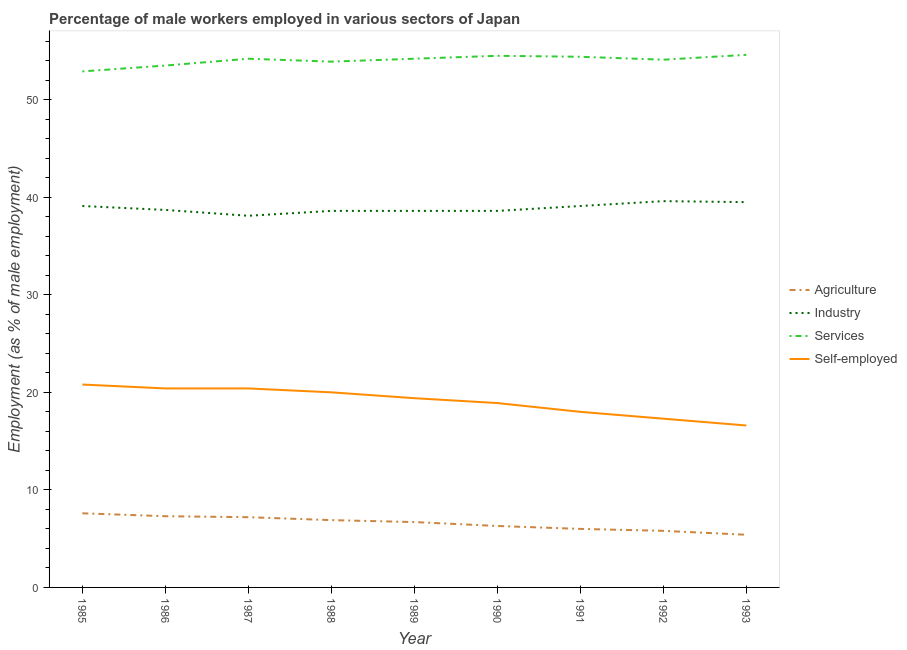How many different coloured lines are there?
Provide a succinct answer. 4. Is the number of lines equal to the number of legend labels?
Your response must be concise. Yes. What is the percentage of male workers in industry in 1992?
Offer a very short reply. 39.6. Across all years, what is the maximum percentage of self employed male workers?
Provide a short and direct response. 20.8. Across all years, what is the minimum percentage of male workers in industry?
Offer a terse response. 38.1. In which year was the percentage of self employed male workers maximum?
Ensure brevity in your answer.  1985. In which year was the percentage of self employed male workers minimum?
Keep it short and to the point. 1993. What is the total percentage of male workers in industry in the graph?
Ensure brevity in your answer.  349.9. What is the difference between the percentage of male workers in agriculture in 1985 and the percentage of male workers in industry in 1986?
Provide a short and direct response. -31.1. What is the average percentage of male workers in agriculture per year?
Give a very brief answer. 6.58. In the year 1985, what is the difference between the percentage of male workers in agriculture and percentage of male workers in industry?
Ensure brevity in your answer.  -31.5. Is the percentage of male workers in services in 1987 less than that in 1992?
Offer a terse response. No. What is the difference between the highest and the second highest percentage of male workers in agriculture?
Offer a very short reply. 0.3. What is the difference between the highest and the lowest percentage of self employed male workers?
Keep it short and to the point. 4.2. In how many years, is the percentage of male workers in agriculture greater than the average percentage of male workers in agriculture taken over all years?
Make the answer very short. 5. Is the sum of the percentage of male workers in industry in 1987 and 1992 greater than the maximum percentage of self employed male workers across all years?
Give a very brief answer. Yes. Is it the case that in every year, the sum of the percentage of male workers in services and percentage of self employed male workers is greater than the sum of percentage of male workers in agriculture and percentage of male workers in industry?
Provide a short and direct response. Yes. Is it the case that in every year, the sum of the percentage of male workers in agriculture and percentage of male workers in industry is greater than the percentage of male workers in services?
Give a very brief answer. No. Does the percentage of male workers in services monotonically increase over the years?
Your response must be concise. No. Is the percentage of male workers in industry strictly greater than the percentage of male workers in services over the years?
Ensure brevity in your answer.  No. Is the percentage of male workers in industry strictly less than the percentage of male workers in services over the years?
Offer a terse response. Yes. How many lines are there?
Keep it short and to the point. 4. Does the graph contain any zero values?
Offer a very short reply. No. What is the title of the graph?
Your answer should be compact. Percentage of male workers employed in various sectors of Japan. What is the label or title of the X-axis?
Your response must be concise. Year. What is the label or title of the Y-axis?
Your answer should be very brief. Employment (as % of male employment). What is the Employment (as % of male employment) in Agriculture in 1985?
Offer a very short reply. 7.6. What is the Employment (as % of male employment) of Industry in 1985?
Give a very brief answer. 39.1. What is the Employment (as % of male employment) of Services in 1985?
Offer a terse response. 52.9. What is the Employment (as % of male employment) of Self-employed in 1985?
Your answer should be very brief. 20.8. What is the Employment (as % of male employment) of Agriculture in 1986?
Make the answer very short. 7.3. What is the Employment (as % of male employment) in Industry in 1986?
Give a very brief answer. 38.7. What is the Employment (as % of male employment) of Services in 1986?
Offer a very short reply. 53.5. What is the Employment (as % of male employment) of Self-employed in 1986?
Your answer should be very brief. 20.4. What is the Employment (as % of male employment) of Agriculture in 1987?
Give a very brief answer. 7.2. What is the Employment (as % of male employment) in Industry in 1987?
Make the answer very short. 38.1. What is the Employment (as % of male employment) of Services in 1987?
Ensure brevity in your answer.  54.2. What is the Employment (as % of male employment) of Self-employed in 1987?
Your answer should be compact. 20.4. What is the Employment (as % of male employment) of Agriculture in 1988?
Make the answer very short. 6.9. What is the Employment (as % of male employment) of Industry in 1988?
Give a very brief answer. 38.6. What is the Employment (as % of male employment) in Services in 1988?
Give a very brief answer. 53.9. What is the Employment (as % of male employment) in Self-employed in 1988?
Provide a succinct answer. 20. What is the Employment (as % of male employment) of Agriculture in 1989?
Your response must be concise. 6.7. What is the Employment (as % of male employment) in Industry in 1989?
Your answer should be very brief. 38.6. What is the Employment (as % of male employment) in Services in 1989?
Provide a short and direct response. 54.2. What is the Employment (as % of male employment) of Self-employed in 1989?
Provide a short and direct response. 19.4. What is the Employment (as % of male employment) in Agriculture in 1990?
Provide a succinct answer. 6.3. What is the Employment (as % of male employment) of Industry in 1990?
Offer a terse response. 38.6. What is the Employment (as % of male employment) of Services in 1990?
Offer a very short reply. 54.5. What is the Employment (as % of male employment) in Self-employed in 1990?
Give a very brief answer. 18.9. What is the Employment (as % of male employment) in Industry in 1991?
Offer a terse response. 39.1. What is the Employment (as % of male employment) of Services in 1991?
Make the answer very short. 54.4. What is the Employment (as % of male employment) of Agriculture in 1992?
Offer a terse response. 5.8. What is the Employment (as % of male employment) in Industry in 1992?
Your answer should be compact. 39.6. What is the Employment (as % of male employment) in Services in 1992?
Offer a terse response. 54.1. What is the Employment (as % of male employment) of Self-employed in 1992?
Your answer should be very brief. 17.3. What is the Employment (as % of male employment) of Agriculture in 1993?
Your answer should be very brief. 5.4. What is the Employment (as % of male employment) of Industry in 1993?
Offer a terse response. 39.5. What is the Employment (as % of male employment) of Services in 1993?
Your answer should be very brief. 54.6. What is the Employment (as % of male employment) in Self-employed in 1993?
Offer a terse response. 16.6. Across all years, what is the maximum Employment (as % of male employment) of Agriculture?
Provide a succinct answer. 7.6. Across all years, what is the maximum Employment (as % of male employment) of Industry?
Ensure brevity in your answer.  39.6. Across all years, what is the maximum Employment (as % of male employment) in Services?
Offer a very short reply. 54.6. Across all years, what is the maximum Employment (as % of male employment) in Self-employed?
Provide a short and direct response. 20.8. Across all years, what is the minimum Employment (as % of male employment) of Agriculture?
Your answer should be compact. 5.4. Across all years, what is the minimum Employment (as % of male employment) of Industry?
Ensure brevity in your answer.  38.1. Across all years, what is the minimum Employment (as % of male employment) in Services?
Give a very brief answer. 52.9. Across all years, what is the minimum Employment (as % of male employment) in Self-employed?
Make the answer very short. 16.6. What is the total Employment (as % of male employment) in Agriculture in the graph?
Offer a terse response. 59.2. What is the total Employment (as % of male employment) in Industry in the graph?
Make the answer very short. 349.9. What is the total Employment (as % of male employment) in Services in the graph?
Provide a short and direct response. 486.3. What is the total Employment (as % of male employment) of Self-employed in the graph?
Provide a short and direct response. 171.8. What is the difference between the Employment (as % of male employment) of Agriculture in 1985 and that in 1986?
Offer a terse response. 0.3. What is the difference between the Employment (as % of male employment) of Industry in 1985 and that in 1986?
Your response must be concise. 0.4. What is the difference between the Employment (as % of male employment) in Services in 1985 and that in 1986?
Provide a succinct answer. -0.6. What is the difference between the Employment (as % of male employment) of Self-employed in 1985 and that in 1986?
Your response must be concise. 0.4. What is the difference between the Employment (as % of male employment) of Services in 1985 and that in 1987?
Provide a short and direct response. -1.3. What is the difference between the Employment (as % of male employment) in Agriculture in 1985 and that in 1988?
Offer a very short reply. 0.7. What is the difference between the Employment (as % of male employment) of Agriculture in 1985 and that in 1989?
Make the answer very short. 0.9. What is the difference between the Employment (as % of male employment) of Industry in 1985 and that in 1989?
Offer a very short reply. 0.5. What is the difference between the Employment (as % of male employment) of Services in 1985 and that in 1989?
Offer a terse response. -1.3. What is the difference between the Employment (as % of male employment) in Self-employed in 1985 and that in 1989?
Ensure brevity in your answer.  1.4. What is the difference between the Employment (as % of male employment) of Agriculture in 1985 and that in 1990?
Offer a terse response. 1.3. What is the difference between the Employment (as % of male employment) of Industry in 1985 and that in 1990?
Provide a short and direct response. 0.5. What is the difference between the Employment (as % of male employment) in Self-employed in 1985 and that in 1990?
Offer a very short reply. 1.9. What is the difference between the Employment (as % of male employment) in Industry in 1985 and that in 1991?
Your answer should be compact. 0. What is the difference between the Employment (as % of male employment) of Services in 1985 and that in 1991?
Keep it short and to the point. -1.5. What is the difference between the Employment (as % of male employment) in Industry in 1985 and that in 1993?
Give a very brief answer. -0.4. What is the difference between the Employment (as % of male employment) in Industry in 1986 and that in 1987?
Offer a very short reply. 0.6. What is the difference between the Employment (as % of male employment) in Services in 1986 and that in 1987?
Offer a very short reply. -0.7. What is the difference between the Employment (as % of male employment) of Industry in 1986 and that in 1988?
Keep it short and to the point. 0.1. What is the difference between the Employment (as % of male employment) in Services in 1986 and that in 1988?
Your answer should be very brief. -0.4. What is the difference between the Employment (as % of male employment) of Agriculture in 1986 and that in 1989?
Provide a short and direct response. 0.6. What is the difference between the Employment (as % of male employment) of Industry in 1986 and that in 1989?
Your response must be concise. 0.1. What is the difference between the Employment (as % of male employment) of Agriculture in 1986 and that in 1990?
Make the answer very short. 1. What is the difference between the Employment (as % of male employment) in Industry in 1986 and that in 1990?
Your answer should be compact. 0.1. What is the difference between the Employment (as % of male employment) of Services in 1986 and that in 1990?
Make the answer very short. -1. What is the difference between the Employment (as % of male employment) in Agriculture in 1986 and that in 1991?
Give a very brief answer. 1.3. What is the difference between the Employment (as % of male employment) of Agriculture in 1986 and that in 1992?
Make the answer very short. 1.5. What is the difference between the Employment (as % of male employment) of Industry in 1986 and that in 1992?
Offer a terse response. -0.9. What is the difference between the Employment (as % of male employment) of Services in 1986 and that in 1992?
Your answer should be very brief. -0.6. What is the difference between the Employment (as % of male employment) in Agriculture in 1986 and that in 1993?
Provide a short and direct response. 1.9. What is the difference between the Employment (as % of male employment) of Services in 1986 and that in 1993?
Provide a short and direct response. -1.1. What is the difference between the Employment (as % of male employment) in Industry in 1987 and that in 1988?
Make the answer very short. -0.5. What is the difference between the Employment (as % of male employment) in Services in 1987 and that in 1988?
Give a very brief answer. 0.3. What is the difference between the Employment (as % of male employment) in Self-employed in 1987 and that in 1988?
Provide a short and direct response. 0.4. What is the difference between the Employment (as % of male employment) in Industry in 1987 and that in 1989?
Keep it short and to the point. -0.5. What is the difference between the Employment (as % of male employment) of Self-employed in 1987 and that in 1989?
Your response must be concise. 1. What is the difference between the Employment (as % of male employment) of Industry in 1987 and that in 1990?
Keep it short and to the point. -0.5. What is the difference between the Employment (as % of male employment) of Self-employed in 1987 and that in 1990?
Offer a very short reply. 1.5. What is the difference between the Employment (as % of male employment) in Agriculture in 1987 and that in 1991?
Provide a short and direct response. 1.2. What is the difference between the Employment (as % of male employment) in Industry in 1987 and that in 1991?
Make the answer very short. -1. What is the difference between the Employment (as % of male employment) of Services in 1987 and that in 1991?
Your answer should be very brief. -0.2. What is the difference between the Employment (as % of male employment) of Self-employed in 1987 and that in 1991?
Your answer should be very brief. 2.4. What is the difference between the Employment (as % of male employment) of Agriculture in 1987 and that in 1992?
Ensure brevity in your answer.  1.4. What is the difference between the Employment (as % of male employment) in Industry in 1987 and that in 1992?
Offer a terse response. -1.5. What is the difference between the Employment (as % of male employment) of Agriculture in 1987 and that in 1993?
Your response must be concise. 1.8. What is the difference between the Employment (as % of male employment) in Services in 1987 and that in 1993?
Provide a succinct answer. -0.4. What is the difference between the Employment (as % of male employment) in Industry in 1988 and that in 1989?
Make the answer very short. 0. What is the difference between the Employment (as % of male employment) in Services in 1988 and that in 1989?
Provide a short and direct response. -0.3. What is the difference between the Employment (as % of male employment) of Industry in 1988 and that in 1990?
Your response must be concise. 0. What is the difference between the Employment (as % of male employment) in Services in 1988 and that in 1990?
Make the answer very short. -0.6. What is the difference between the Employment (as % of male employment) of Industry in 1988 and that in 1991?
Offer a terse response. -0.5. What is the difference between the Employment (as % of male employment) of Services in 1988 and that in 1991?
Give a very brief answer. -0.5. What is the difference between the Employment (as % of male employment) in Services in 1988 and that in 1992?
Provide a short and direct response. -0.2. What is the difference between the Employment (as % of male employment) in Services in 1988 and that in 1993?
Your answer should be very brief. -0.7. What is the difference between the Employment (as % of male employment) in Self-employed in 1988 and that in 1993?
Give a very brief answer. 3.4. What is the difference between the Employment (as % of male employment) of Industry in 1989 and that in 1990?
Keep it short and to the point. 0. What is the difference between the Employment (as % of male employment) of Industry in 1989 and that in 1991?
Your answer should be very brief. -0.5. What is the difference between the Employment (as % of male employment) in Services in 1989 and that in 1991?
Offer a terse response. -0.2. What is the difference between the Employment (as % of male employment) in Self-employed in 1989 and that in 1991?
Offer a terse response. 1.4. What is the difference between the Employment (as % of male employment) in Agriculture in 1989 and that in 1992?
Your answer should be compact. 0.9. What is the difference between the Employment (as % of male employment) in Industry in 1989 and that in 1993?
Provide a short and direct response. -0.9. What is the difference between the Employment (as % of male employment) in Services in 1989 and that in 1993?
Offer a terse response. -0.4. What is the difference between the Employment (as % of male employment) in Industry in 1990 and that in 1991?
Provide a succinct answer. -0.5. What is the difference between the Employment (as % of male employment) of Services in 1990 and that in 1991?
Ensure brevity in your answer.  0.1. What is the difference between the Employment (as % of male employment) in Services in 1990 and that in 1992?
Provide a short and direct response. 0.4. What is the difference between the Employment (as % of male employment) of Agriculture in 1990 and that in 1993?
Your answer should be compact. 0.9. What is the difference between the Employment (as % of male employment) of Industry in 1990 and that in 1993?
Keep it short and to the point. -0.9. What is the difference between the Employment (as % of male employment) of Services in 1990 and that in 1993?
Your response must be concise. -0.1. What is the difference between the Employment (as % of male employment) of Agriculture in 1991 and that in 1992?
Keep it short and to the point. 0.2. What is the difference between the Employment (as % of male employment) of Services in 1991 and that in 1992?
Offer a very short reply. 0.3. What is the difference between the Employment (as % of male employment) in Agriculture in 1991 and that in 1993?
Keep it short and to the point. 0.6. What is the difference between the Employment (as % of male employment) of Services in 1991 and that in 1993?
Ensure brevity in your answer.  -0.2. What is the difference between the Employment (as % of male employment) in Self-employed in 1992 and that in 1993?
Keep it short and to the point. 0.7. What is the difference between the Employment (as % of male employment) in Agriculture in 1985 and the Employment (as % of male employment) in Industry in 1986?
Your answer should be compact. -31.1. What is the difference between the Employment (as % of male employment) of Agriculture in 1985 and the Employment (as % of male employment) of Services in 1986?
Make the answer very short. -45.9. What is the difference between the Employment (as % of male employment) in Industry in 1985 and the Employment (as % of male employment) in Services in 1986?
Ensure brevity in your answer.  -14.4. What is the difference between the Employment (as % of male employment) of Industry in 1985 and the Employment (as % of male employment) of Self-employed in 1986?
Your answer should be compact. 18.7. What is the difference between the Employment (as % of male employment) of Services in 1985 and the Employment (as % of male employment) of Self-employed in 1986?
Provide a succinct answer. 32.5. What is the difference between the Employment (as % of male employment) in Agriculture in 1985 and the Employment (as % of male employment) in Industry in 1987?
Provide a short and direct response. -30.5. What is the difference between the Employment (as % of male employment) of Agriculture in 1985 and the Employment (as % of male employment) of Services in 1987?
Ensure brevity in your answer.  -46.6. What is the difference between the Employment (as % of male employment) of Agriculture in 1985 and the Employment (as % of male employment) of Self-employed in 1987?
Your response must be concise. -12.8. What is the difference between the Employment (as % of male employment) of Industry in 1985 and the Employment (as % of male employment) of Services in 1987?
Make the answer very short. -15.1. What is the difference between the Employment (as % of male employment) of Industry in 1985 and the Employment (as % of male employment) of Self-employed in 1987?
Your answer should be compact. 18.7. What is the difference between the Employment (as % of male employment) in Services in 1985 and the Employment (as % of male employment) in Self-employed in 1987?
Make the answer very short. 32.5. What is the difference between the Employment (as % of male employment) of Agriculture in 1985 and the Employment (as % of male employment) of Industry in 1988?
Your answer should be compact. -31. What is the difference between the Employment (as % of male employment) of Agriculture in 1985 and the Employment (as % of male employment) of Services in 1988?
Provide a succinct answer. -46.3. What is the difference between the Employment (as % of male employment) in Industry in 1985 and the Employment (as % of male employment) in Services in 1988?
Offer a terse response. -14.8. What is the difference between the Employment (as % of male employment) of Industry in 1985 and the Employment (as % of male employment) of Self-employed in 1988?
Your answer should be compact. 19.1. What is the difference between the Employment (as % of male employment) in Services in 1985 and the Employment (as % of male employment) in Self-employed in 1988?
Make the answer very short. 32.9. What is the difference between the Employment (as % of male employment) of Agriculture in 1985 and the Employment (as % of male employment) of Industry in 1989?
Make the answer very short. -31. What is the difference between the Employment (as % of male employment) of Agriculture in 1985 and the Employment (as % of male employment) of Services in 1989?
Provide a succinct answer. -46.6. What is the difference between the Employment (as % of male employment) of Agriculture in 1985 and the Employment (as % of male employment) of Self-employed in 1989?
Ensure brevity in your answer.  -11.8. What is the difference between the Employment (as % of male employment) of Industry in 1985 and the Employment (as % of male employment) of Services in 1989?
Make the answer very short. -15.1. What is the difference between the Employment (as % of male employment) of Services in 1985 and the Employment (as % of male employment) of Self-employed in 1989?
Offer a very short reply. 33.5. What is the difference between the Employment (as % of male employment) in Agriculture in 1985 and the Employment (as % of male employment) in Industry in 1990?
Provide a short and direct response. -31. What is the difference between the Employment (as % of male employment) of Agriculture in 1985 and the Employment (as % of male employment) of Services in 1990?
Offer a terse response. -46.9. What is the difference between the Employment (as % of male employment) of Industry in 1985 and the Employment (as % of male employment) of Services in 1990?
Offer a very short reply. -15.4. What is the difference between the Employment (as % of male employment) in Industry in 1985 and the Employment (as % of male employment) in Self-employed in 1990?
Ensure brevity in your answer.  20.2. What is the difference between the Employment (as % of male employment) of Agriculture in 1985 and the Employment (as % of male employment) of Industry in 1991?
Your response must be concise. -31.5. What is the difference between the Employment (as % of male employment) of Agriculture in 1985 and the Employment (as % of male employment) of Services in 1991?
Keep it short and to the point. -46.8. What is the difference between the Employment (as % of male employment) in Agriculture in 1985 and the Employment (as % of male employment) in Self-employed in 1991?
Offer a terse response. -10.4. What is the difference between the Employment (as % of male employment) of Industry in 1985 and the Employment (as % of male employment) of Services in 1991?
Provide a short and direct response. -15.3. What is the difference between the Employment (as % of male employment) of Industry in 1985 and the Employment (as % of male employment) of Self-employed in 1991?
Offer a very short reply. 21.1. What is the difference between the Employment (as % of male employment) in Services in 1985 and the Employment (as % of male employment) in Self-employed in 1991?
Provide a succinct answer. 34.9. What is the difference between the Employment (as % of male employment) in Agriculture in 1985 and the Employment (as % of male employment) in Industry in 1992?
Ensure brevity in your answer.  -32. What is the difference between the Employment (as % of male employment) in Agriculture in 1985 and the Employment (as % of male employment) in Services in 1992?
Offer a very short reply. -46.5. What is the difference between the Employment (as % of male employment) of Industry in 1985 and the Employment (as % of male employment) of Services in 1992?
Make the answer very short. -15. What is the difference between the Employment (as % of male employment) in Industry in 1985 and the Employment (as % of male employment) in Self-employed in 1992?
Make the answer very short. 21.8. What is the difference between the Employment (as % of male employment) in Services in 1985 and the Employment (as % of male employment) in Self-employed in 1992?
Offer a very short reply. 35.6. What is the difference between the Employment (as % of male employment) in Agriculture in 1985 and the Employment (as % of male employment) in Industry in 1993?
Your response must be concise. -31.9. What is the difference between the Employment (as % of male employment) in Agriculture in 1985 and the Employment (as % of male employment) in Services in 1993?
Ensure brevity in your answer.  -47. What is the difference between the Employment (as % of male employment) of Industry in 1985 and the Employment (as % of male employment) of Services in 1993?
Provide a short and direct response. -15.5. What is the difference between the Employment (as % of male employment) in Services in 1985 and the Employment (as % of male employment) in Self-employed in 1993?
Keep it short and to the point. 36.3. What is the difference between the Employment (as % of male employment) of Agriculture in 1986 and the Employment (as % of male employment) of Industry in 1987?
Your answer should be very brief. -30.8. What is the difference between the Employment (as % of male employment) of Agriculture in 1986 and the Employment (as % of male employment) of Services in 1987?
Provide a succinct answer. -46.9. What is the difference between the Employment (as % of male employment) of Industry in 1986 and the Employment (as % of male employment) of Services in 1987?
Offer a very short reply. -15.5. What is the difference between the Employment (as % of male employment) of Services in 1986 and the Employment (as % of male employment) of Self-employed in 1987?
Your answer should be compact. 33.1. What is the difference between the Employment (as % of male employment) in Agriculture in 1986 and the Employment (as % of male employment) in Industry in 1988?
Provide a succinct answer. -31.3. What is the difference between the Employment (as % of male employment) of Agriculture in 1986 and the Employment (as % of male employment) of Services in 1988?
Offer a terse response. -46.6. What is the difference between the Employment (as % of male employment) in Industry in 1986 and the Employment (as % of male employment) in Services in 1988?
Give a very brief answer. -15.2. What is the difference between the Employment (as % of male employment) of Industry in 1986 and the Employment (as % of male employment) of Self-employed in 1988?
Provide a short and direct response. 18.7. What is the difference between the Employment (as % of male employment) of Services in 1986 and the Employment (as % of male employment) of Self-employed in 1988?
Provide a succinct answer. 33.5. What is the difference between the Employment (as % of male employment) in Agriculture in 1986 and the Employment (as % of male employment) in Industry in 1989?
Give a very brief answer. -31.3. What is the difference between the Employment (as % of male employment) of Agriculture in 1986 and the Employment (as % of male employment) of Services in 1989?
Ensure brevity in your answer.  -46.9. What is the difference between the Employment (as % of male employment) of Agriculture in 1986 and the Employment (as % of male employment) of Self-employed in 1989?
Offer a terse response. -12.1. What is the difference between the Employment (as % of male employment) in Industry in 1986 and the Employment (as % of male employment) in Services in 1989?
Offer a terse response. -15.5. What is the difference between the Employment (as % of male employment) in Industry in 1986 and the Employment (as % of male employment) in Self-employed in 1989?
Ensure brevity in your answer.  19.3. What is the difference between the Employment (as % of male employment) in Services in 1986 and the Employment (as % of male employment) in Self-employed in 1989?
Offer a terse response. 34.1. What is the difference between the Employment (as % of male employment) in Agriculture in 1986 and the Employment (as % of male employment) in Industry in 1990?
Make the answer very short. -31.3. What is the difference between the Employment (as % of male employment) of Agriculture in 1986 and the Employment (as % of male employment) of Services in 1990?
Ensure brevity in your answer.  -47.2. What is the difference between the Employment (as % of male employment) in Industry in 1986 and the Employment (as % of male employment) in Services in 1990?
Your response must be concise. -15.8. What is the difference between the Employment (as % of male employment) in Industry in 1986 and the Employment (as % of male employment) in Self-employed in 1990?
Your answer should be very brief. 19.8. What is the difference between the Employment (as % of male employment) in Services in 1986 and the Employment (as % of male employment) in Self-employed in 1990?
Provide a succinct answer. 34.6. What is the difference between the Employment (as % of male employment) of Agriculture in 1986 and the Employment (as % of male employment) of Industry in 1991?
Your response must be concise. -31.8. What is the difference between the Employment (as % of male employment) of Agriculture in 1986 and the Employment (as % of male employment) of Services in 1991?
Provide a succinct answer. -47.1. What is the difference between the Employment (as % of male employment) in Agriculture in 1986 and the Employment (as % of male employment) in Self-employed in 1991?
Provide a succinct answer. -10.7. What is the difference between the Employment (as % of male employment) in Industry in 1986 and the Employment (as % of male employment) in Services in 1991?
Provide a short and direct response. -15.7. What is the difference between the Employment (as % of male employment) of Industry in 1986 and the Employment (as % of male employment) of Self-employed in 1991?
Ensure brevity in your answer.  20.7. What is the difference between the Employment (as % of male employment) in Services in 1986 and the Employment (as % of male employment) in Self-employed in 1991?
Your answer should be very brief. 35.5. What is the difference between the Employment (as % of male employment) in Agriculture in 1986 and the Employment (as % of male employment) in Industry in 1992?
Your response must be concise. -32.3. What is the difference between the Employment (as % of male employment) in Agriculture in 1986 and the Employment (as % of male employment) in Services in 1992?
Your answer should be very brief. -46.8. What is the difference between the Employment (as % of male employment) in Agriculture in 1986 and the Employment (as % of male employment) in Self-employed in 1992?
Your answer should be very brief. -10. What is the difference between the Employment (as % of male employment) of Industry in 1986 and the Employment (as % of male employment) of Services in 1992?
Your answer should be compact. -15.4. What is the difference between the Employment (as % of male employment) in Industry in 1986 and the Employment (as % of male employment) in Self-employed in 1992?
Provide a short and direct response. 21.4. What is the difference between the Employment (as % of male employment) of Services in 1986 and the Employment (as % of male employment) of Self-employed in 1992?
Provide a succinct answer. 36.2. What is the difference between the Employment (as % of male employment) of Agriculture in 1986 and the Employment (as % of male employment) of Industry in 1993?
Ensure brevity in your answer.  -32.2. What is the difference between the Employment (as % of male employment) of Agriculture in 1986 and the Employment (as % of male employment) of Services in 1993?
Give a very brief answer. -47.3. What is the difference between the Employment (as % of male employment) of Industry in 1986 and the Employment (as % of male employment) of Services in 1993?
Your answer should be compact. -15.9. What is the difference between the Employment (as % of male employment) in Industry in 1986 and the Employment (as % of male employment) in Self-employed in 1993?
Your response must be concise. 22.1. What is the difference between the Employment (as % of male employment) of Services in 1986 and the Employment (as % of male employment) of Self-employed in 1993?
Ensure brevity in your answer.  36.9. What is the difference between the Employment (as % of male employment) in Agriculture in 1987 and the Employment (as % of male employment) in Industry in 1988?
Your answer should be very brief. -31.4. What is the difference between the Employment (as % of male employment) in Agriculture in 1987 and the Employment (as % of male employment) in Services in 1988?
Give a very brief answer. -46.7. What is the difference between the Employment (as % of male employment) of Agriculture in 1987 and the Employment (as % of male employment) of Self-employed in 1988?
Give a very brief answer. -12.8. What is the difference between the Employment (as % of male employment) of Industry in 1987 and the Employment (as % of male employment) of Services in 1988?
Make the answer very short. -15.8. What is the difference between the Employment (as % of male employment) of Services in 1987 and the Employment (as % of male employment) of Self-employed in 1988?
Make the answer very short. 34.2. What is the difference between the Employment (as % of male employment) of Agriculture in 1987 and the Employment (as % of male employment) of Industry in 1989?
Give a very brief answer. -31.4. What is the difference between the Employment (as % of male employment) of Agriculture in 1987 and the Employment (as % of male employment) of Services in 1989?
Make the answer very short. -47. What is the difference between the Employment (as % of male employment) of Agriculture in 1987 and the Employment (as % of male employment) of Self-employed in 1989?
Offer a terse response. -12.2. What is the difference between the Employment (as % of male employment) of Industry in 1987 and the Employment (as % of male employment) of Services in 1989?
Ensure brevity in your answer.  -16.1. What is the difference between the Employment (as % of male employment) of Services in 1987 and the Employment (as % of male employment) of Self-employed in 1989?
Keep it short and to the point. 34.8. What is the difference between the Employment (as % of male employment) in Agriculture in 1987 and the Employment (as % of male employment) in Industry in 1990?
Keep it short and to the point. -31.4. What is the difference between the Employment (as % of male employment) of Agriculture in 1987 and the Employment (as % of male employment) of Services in 1990?
Give a very brief answer. -47.3. What is the difference between the Employment (as % of male employment) of Industry in 1987 and the Employment (as % of male employment) of Services in 1990?
Give a very brief answer. -16.4. What is the difference between the Employment (as % of male employment) of Services in 1987 and the Employment (as % of male employment) of Self-employed in 1990?
Provide a succinct answer. 35.3. What is the difference between the Employment (as % of male employment) in Agriculture in 1987 and the Employment (as % of male employment) in Industry in 1991?
Your answer should be compact. -31.9. What is the difference between the Employment (as % of male employment) of Agriculture in 1987 and the Employment (as % of male employment) of Services in 1991?
Offer a very short reply. -47.2. What is the difference between the Employment (as % of male employment) of Agriculture in 1987 and the Employment (as % of male employment) of Self-employed in 1991?
Provide a short and direct response. -10.8. What is the difference between the Employment (as % of male employment) of Industry in 1987 and the Employment (as % of male employment) of Services in 1991?
Your response must be concise. -16.3. What is the difference between the Employment (as % of male employment) in Industry in 1987 and the Employment (as % of male employment) in Self-employed in 1991?
Make the answer very short. 20.1. What is the difference between the Employment (as % of male employment) of Services in 1987 and the Employment (as % of male employment) of Self-employed in 1991?
Give a very brief answer. 36.2. What is the difference between the Employment (as % of male employment) of Agriculture in 1987 and the Employment (as % of male employment) of Industry in 1992?
Provide a succinct answer. -32.4. What is the difference between the Employment (as % of male employment) of Agriculture in 1987 and the Employment (as % of male employment) of Services in 1992?
Offer a very short reply. -46.9. What is the difference between the Employment (as % of male employment) of Industry in 1987 and the Employment (as % of male employment) of Self-employed in 1992?
Your response must be concise. 20.8. What is the difference between the Employment (as % of male employment) of Services in 1987 and the Employment (as % of male employment) of Self-employed in 1992?
Your answer should be very brief. 36.9. What is the difference between the Employment (as % of male employment) in Agriculture in 1987 and the Employment (as % of male employment) in Industry in 1993?
Your response must be concise. -32.3. What is the difference between the Employment (as % of male employment) of Agriculture in 1987 and the Employment (as % of male employment) of Services in 1993?
Keep it short and to the point. -47.4. What is the difference between the Employment (as % of male employment) in Agriculture in 1987 and the Employment (as % of male employment) in Self-employed in 1993?
Your answer should be compact. -9.4. What is the difference between the Employment (as % of male employment) of Industry in 1987 and the Employment (as % of male employment) of Services in 1993?
Your answer should be very brief. -16.5. What is the difference between the Employment (as % of male employment) in Industry in 1987 and the Employment (as % of male employment) in Self-employed in 1993?
Your response must be concise. 21.5. What is the difference between the Employment (as % of male employment) in Services in 1987 and the Employment (as % of male employment) in Self-employed in 1993?
Keep it short and to the point. 37.6. What is the difference between the Employment (as % of male employment) in Agriculture in 1988 and the Employment (as % of male employment) in Industry in 1989?
Your response must be concise. -31.7. What is the difference between the Employment (as % of male employment) of Agriculture in 1988 and the Employment (as % of male employment) of Services in 1989?
Your answer should be very brief. -47.3. What is the difference between the Employment (as % of male employment) of Agriculture in 1988 and the Employment (as % of male employment) of Self-employed in 1989?
Offer a terse response. -12.5. What is the difference between the Employment (as % of male employment) in Industry in 1988 and the Employment (as % of male employment) in Services in 1989?
Your answer should be compact. -15.6. What is the difference between the Employment (as % of male employment) in Services in 1988 and the Employment (as % of male employment) in Self-employed in 1989?
Provide a short and direct response. 34.5. What is the difference between the Employment (as % of male employment) in Agriculture in 1988 and the Employment (as % of male employment) in Industry in 1990?
Your response must be concise. -31.7. What is the difference between the Employment (as % of male employment) in Agriculture in 1988 and the Employment (as % of male employment) in Services in 1990?
Your answer should be very brief. -47.6. What is the difference between the Employment (as % of male employment) in Industry in 1988 and the Employment (as % of male employment) in Services in 1990?
Keep it short and to the point. -15.9. What is the difference between the Employment (as % of male employment) of Industry in 1988 and the Employment (as % of male employment) of Self-employed in 1990?
Offer a very short reply. 19.7. What is the difference between the Employment (as % of male employment) in Agriculture in 1988 and the Employment (as % of male employment) in Industry in 1991?
Your response must be concise. -32.2. What is the difference between the Employment (as % of male employment) in Agriculture in 1988 and the Employment (as % of male employment) in Services in 1991?
Give a very brief answer. -47.5. What is the difference between the Employment (as % of male employment) of Industry in 1988 and the Employment (as % of male employment) of Services in 1991?
Provide a succinct answer. -15.8. What is the difference between the Employment (as % of male employment) in Industry in 1988 and the Employment (as % of male employment) in Self-employed in 1991?
Offer a terse response. 20.6. What is the difference between the Employment (as % of male employment) of Services in 1988 and the Employment (as % of male employment) of Self-employed in 1991?
Your response must be concise. 35.9. What is the difference between the Employment (as % of male employment) of Agriculture in 1988 and the Employment (as % of male employment) of Industry in 1992?
Your answer should be compact. -32.7. What is the difference between the Employment (as % of male employment) of Agriculture in 1988 and the Employment (as % of male employment) of Services in 1992?
Give a very brief answer. -47.2. What is the difference between the Employment (as % of male employment) of Industry in 1988 and the Employment (as % of male employment) of Services in 1992?
Ensure brevity in your answer.  -15.5. What is the difference between the Employment (as % of male employment) of Industry in 1988 and the Employment (as % of male employment) of Self-employed in 1992?
Make the answer very short. 21.3. What is the difference between the Employment (as % of male employment) in Services in 1988 and the Employment (as % of male employment) in Self-employed in 1992?
Provide a succinct answer. 36.6. What is the difference between the Employment (as % of male employment) of Agriculture in 1988 and the Employment (as % of male employment) of Industry in 1993?
Offer a terse response. -32.6. What is the difference between the Employment (as % of male employment) of Agriculture in 1988 and the Employment (as % of male employment) of Services in 1993?
Offer a terse response. -47.7. What is the difference between the Employment (as % of male employment) of Agriculture in 1988 and the Employment (as % of male employment) of Self-employed in 1993?
Keep it short and to the point. -9.7. What is the difference between the Employment (as % of male employment) of Industry in 1988 and the Employment (as % of male employment) of Services in 1993?
Make the answer very short. -16. What is the difference between the Employment (as % of male employment) in Services in 1988 and the Employment (as % of male employment) in Self-employed in 1993?
Provide a short and direct response. 37.3. What is the difference between the Employment (as % of male employment) in Agriculture in 1989 and the Employment (as % of male employment) in Industry in 1990?
Your answer should be compact. -31.9. What is the difference between the Employment (as % of male employment) of Agriculture in 1989 and the Employment (as % of male employment) of Services in 1990?
Ensure brevity in your answer.  -47.8. What is the difference between the Employment (as % of male employment) in Industry in 1989 and the Employment (as % of male employment) in Services in 1990?
Provide a succinct answer. -15.9. What is the difference between the Employment (as % of male employment) in Industry in 1989 and the Employment (as % of male employment) in Self-employed in 1990?
Provide a succinct answer. 19.7. What is the difference between the Employment (as % of male employment) in Services in 1989 and the Employment (as % of male employment) in Self-employed in 1990?
Your answer should be compact. 35.3. What is the difference between the Employment (as % of male employment) in Agriculture in 1989 and the Employment (as % of male employment) in Industry in 1991?
Provide a succinct answer. -32.4. What is the difference between the Employment (as % of male employment) of Agriculture in 1989 and the Employment (as % of male employment) of Services in 1991?
Offer a very short reply. -47.7. What is the difference between the Employment (as % of male employment) in Industry in 1989 and the Employment (as % of male employment) in Services in 1991?
Ensure brevity in your answer.  -15.8. What is the difference between the Employment (as % of male employment) in Industry in 1989 and the Employment (as % of male employment) in Self-employed in 1991?
Your answer should be very brief. 20.6. What is the difference between the Employment (as % of male employment) in Services in 1989 and the Employment (as % of male employment) in Self-employed in 1991?
Offer a terse response. 36.2. What is the difference between the Employment (as % of male employment) of Agriculture in 1989 and the Employment (as % of male employment) of Industry in 1992?
Your answer should be compact. -32.9. What is the difference between the Employment (as % of male employment) of Agriculture in 1989 and the Employment (as % of male employment) of Services in 1992?
Offer a terse response. -47.4. What is the difference between the Employment (as % of male employment) in Industry in 1989 and the Employment (as % of male employment) in Services in 1992?
Keep it short and to the point. -15.5. What is the difference between the Employment (as % of male employment) in Industry in 1989 and the Employment (as % of male employment) in Self-employed in 1992?
Make the answer very short. 21.3. What is the difference between the Employment (as % of male employment) of Services in 1989 and the Employment (as % of male employment) of Self-employed in 1992?
Make the answer very short. 36.9. What is the difference between the Employment (as % of male employment) in Agriculture in 1989 and the Employment (as % of male employment) in Industry in 1993?
Your answer should be compact. -32.8. What is the difference between the Employment (as % of male employment) in Agriculture in 1989 and the Employment (as % of male employment) in Services in 1993?
Make the answer very short. -47.9. What is the difference between the Employment (as % of male employment) in Agriculture in 1989 and the Employment (as % of male employment) in Self-employed in 1993?
Ensure brevity in your answer.  -9.9. What is the difference between the Employment (as % of male employment) of Services in 1989 and the Employment (as % of male employment) of Self-employed in 1993?
Provide a short and direct response. 37.6. What is the difference between the Employment (as % of male employment) of Agriculture in 1990 and the Employment (as % of male employment) of Industry in 1991?
Keep it short and to the point. -32.8. What is the difference between the Employment (as % of male employment) in Agriculture in 1990 and the Employment (as % of male employment) in Services in 1991?
Make the answer very short. -48.1. What is the difference between the Employment (as % of male employment) in Agriculture in 1990 and the Employment (as % of male employment) in Self-employed in 1991?
Keep it short and to the point. -11.7. What is the difference between the Employment (as % of male employment) of Industry in 1990 and the Employment (as % of male employment) of Services in 1991?
Offer a terse response. -15.8. What is the difference between the Employment (as % of male employment) of Industry in 1990 and the Employment (as % of male employment) of Self-employed in 1991?
Your answer should be very brief. 20.6. What is the difference between the Employment (as % of male employment) of Services in 1990 and the Employment (as % of male employment) of Self-employed in 1991?
Your answer should be very brief. 36.5. What is the difference between the Employment (as % of male employment) in Agriculture in 1990 and the Employment (as % of male employment) in Industry in 1992?
Provide a short and direct response. -33.3. What is the difference between the Employment (as % of male employment) in Agriculture in 1990 and the Employment (as % of male employment) in Services in 1992?
Your answer should be very brief. -47.8. What is the difference between the Employment (as % of male employment) in Industry in 1990 and the Employment (as % of male employment) in Services in 1992?
Your answer should be compact. -15.5. What is the difference between the Employment (as % of male employment) in Industry in 1990 and the Employment (as % of male employment) in Self-employed in 1992?
Ensure brevity in your answer.  21.3. What is the difference between the Employment (as % of male employment) of Services in 1990 and the Employment (as % of male employment) of Self-employed in 1992?
Offer a terse response. 37.2. What is the difference between the Employment (as % of male employment) in Agriculture in 1990 and the Employment (as % of male employment) in Industry in 1993?
Your answer should be compact. -33.2. What is the difference between the Employment (as % of male employment) in Agriculture in 1990 and the Employment (as % of male employment) in Services in 1993?
Offer a very short reply. -48.3. What is the difference between the Employment (as % of male employment) of Agriculture in 1990 and the Employment (as % of male employment) of Self-employed in 1993?
Keep it short and to the point. -10.3. What is the difference between the Employment (as % of male employment) in Industry in 1990 and the Employment (as % of male employment) in Self-employed in 1993?
Offer a terse response. 22. What is the difference between the Employment (as % of male employment) of Services in 1990 and the Employment (as % of male employment) of Self-employed in 1993?
Provide a short and direct response. 37.9. What is the difference between the Employment (as % of male employment) of Agriculture in 1991 and the Employment (as % of male employment) of Industry in 1992?
Offer a terse response. -33.6. What is the difference between the Employment (as % of male employment) in Agriculture in 1991 and the Employment (as % of male employment) in Services in 1992?
Your response must be concise. -48.1. What is the difference between the Employment (as % of male employment) of Industry in 1991 and the Employment (as % of male employment) of Self-employed in 1992?
Keep it short and to the point. 21.8. What is the difference between the Employment (as % of male employment) in Services in 1991 and the Employment (as % of male employment) in Self-employed in 1992?
Provide a short and direct response. 37.1. What is the difference between the Employment (as % of male employment) of Agriculture in 1991 and the Employment (as % of male employment) of Industry in 1993?
Your response must be concise. -33.5. What is the difference between the Employment (as % of male employment) of Agriculture in 1991 and the Employment (as % of male employment) of Services in 1993?
Offer a very short reply. -48.6. What is the difference between the Employment (as % of male employment) in Industry in 1991 and the Employment (as % of male employment) in Services in 1993?
Make the answer very short. -15.5. What is the difference between the Employment (as % of male employment) in Services in 1991 and the Employment (as % of male employment) in Self-employed in 1993?
Ensure brevity in your answer.  37.8. What is the difference between the Employment (as % of male employment) of Agriculture in 1992 and the Employment (as % of male employment) of Industry in 1993?
Provide a short and direct response. -33.7. What is the difference between the Employment (as % of male employment) in Agriculture in 1992 and the Employment (as % of male employment) in Services in 1993?
Your answer should be compact. -48.8. What is the difference between the Employment (as % of male employment) of Services in 1992 and the Employment (as % of male employment) of Self-employed in 1993?
Offer a terse response. 37.5. What is the average Employment (as % of male employment) of Agriculture per year?
Give a very brief answer. 6.58. What is the average Employment (as % of male employment) of Industry per year?
Your answer should be compact. 38.88. What is the average Employment (as % of male employment) of Services per year?
Keep it short and to the point. 54.03. What is the average Employment (as % of male employment) in Self-employed per year?
Provide a short and direct response. 19.09. In the year 1985, what is the difference between the Employment (as % of male employment) of Agriculture and Employment (as % of male employment) of Industry?
Your answer should be compact. -31.5. In the year 1985, what is the difference between the Employment (as % of male employment) in Agriculture and Employment (as % of male employment) in Services?
Offer a very short reply. -45.3. In the year 1985, what is the difference between the Employment (as % of male employment) in Agriculture and Employment (as % of male employment) in Self-employed?
Give a very brief answer. -13.2. In the year 1985, what is the difference between the Employment (as % of male employment) of Industry and Employment (as % of male employment) of Services?
Make the answer very short. -13.8. In the year 1985, what is the difference between the Employment (as % of male employment) in Industry and Employment (as % of male employment) in Self-employed?
Provide a short and direct response. 18.3. In the year 1985, what is the difference between the Employment (as % of male employment) in Services and Employment (as % of male employment) in Self-employed?
Make the answer very short. 32.1. In the year 1986, what is the difference between the Employment (as % of male employment) in Agriculture and Employment (as % of male employment) in Industry?
Keep it short and to the point. -31.4. In the year 1986, what is the difference between the Employment (as % of male employment) in Agriculture and Employment (as % of male employment) in Services?
Ensure brevity in your answer.  -46.2. In the year 1986, what is the difference between the Employment (as % of male employment) in Industry and Employment (as % of male employment) in Services?
Provide a short and direct response. -14.8. In the year 1986, what is the difference between the Employment (as % of male employment) of Industry and Employment (as % of male employment) of Self-employed?
Your answer should be compact. 18.3. In the year 1986, what is the difference between the Employment (as % of male employment) in Services and Employment (as % of male employment) in Self-employed?
Your answer should be compact. 33.1. In the year 1987, what is the difference between the Employment (as % of male employment) in Agriculture and Employment (as % of male employment) in Industry?
Your response must be concise. -30.9. In the year 1987, what is the difference between the Employment (as % of male employment) of Agriculture and Employment (as % of male employment) of Services?
Your answer should be very brief. -47. In the year 1987, what is the difference between the Employment (as % of male employment) in Industry and Employment (as % of male employment) in Services?
Keep it short and to the point. -16.1. In the year 1987, what is the difference between the Employment (as % of male employment) of Industry and Employment (as % of male employment) of Self-employed?
Give a very brief answer. 17.7. In the year 1987, what is the difference between the Employment (as % of male employment) of Services and Employment (as % of male employment) of Self-employed?
Provide a succinct answer. 33.8. In the year 1988, what is the difference between the Employment (as % of male employment) of Agriculture and Employment (as % of male employment) of Industry?
Provide a succinct answer. -31.7. In the year 1988, what is the difference between the Employment (as % of male employment) in Agriculture and Employment (as % of male employment) in Services?
Provide a short and direct response. -47. In the year 1988, what is the difference between the Employment (as % of male employment) in Agriculture and Employment (as % of male employment) in Self-employed?
Offer a very short reply. -13.1. In the year 1988, what is the difference between the Employment (as % of male employment) in Industry and Employment (as % of male employment) in Services?
Ensure brevity in your answer.  -15.3. In the year 1988, what is the difference between the Employment (as % of male employment) of Services and Employment (as % of male employment) of Self-employed?
Offer a very short reply. 33.9. In the year 1989, what is the difference between the Employment (as % of male employment) in Agriculture and Employment (as % of male employment) in Industry?
Keep it short and to the point. -31.9. In the year 1989, what is the difference between the Employment (as % of male employment) in Agriculture and Employment (as % of male employment) in Services?
Offer a very short reply. -47.5. In the year 1989, what is the difference between the Employment (as % of male employment) in Agriculture and Employment (as % of male employment) in Self-employed?
Give a very brief answer. -12.7. In the year 1989, what is the difference between the Employment (as % of male employment) in Industry and Employment (as % of male employment) in Services?
Your answer should be compact. -15.6. In the year 1989, what is the difference between the Employment (as % of male employment) in Services and Employment (as % of male employment) in Self-employed?
Your answer should be very brief. 34.8. In the year 1990, what is the difference between the Employment (as % of male employment) of Agriculture and Employment (as % of male employment) of Industry?
Make the answer very short. -32.3. In the year 1990, what is the difference between the Employment (as % of male employment) of Agriculture and Employment (as % of male employment) of Services?
Ensure brevity in your answer.  -48.2. In the year 1990, what is the difference between the Employment (as % of male employment) in Agriculture and Employment (as % of male employment) in Self-employed?
Offer a very short reply. -12.6. In the year 1990, what is the difference between the Employment (as % of male employment) in Industry and Employment (as % of male employment) in Services?
Keep it short and to the point. -15.9. In the year 1990, what is the difference between the Employment (as % of male employment) of Industry and Employment (as % of male employment) of Self-employed?
Provide a succinct answer. 19.7. In the year 1990, what is the difference between the Employment (as % of male employment) in Services and Employment (as % of male employment) in Self-employed?
Your answer should be very brief. 35.6. In the year 1991, what is the difference between the Employment (as % of male employment) in Agriculture and Employment (as % of male employment) in Industry?
Your response must be concise. -33.1. In the year 1991, what is the difference between the Employment (as % of male employment) in Agriculture and Employment (as % of male employment) in Services?
Make the answer very short. -48.4. In the year 1991, what is the difference between the Employment (as % of male employment) in Industry and Employment (as % of male employment) in Services?
Provide a short and direct response. -15.3. In the year 1991, what is the difference between the Employment (as % of male employment) of Industry and Employment (as % of male employment) of Self-employed?
Ensure brevity in your answer.  21.1. In the year 1991, what is the difference between the Employment (as % of male employment) in Services and Employment (as % of male employment) in Self-employed?
Your response must be concise. 36.4. In the year 1992, what is the difference between the Employment (as % of male employment) of Agriculture and Employment (as % of male employment) of Industry?
Provide a succinct answer. -33.8. In the year 1992, what is the difference between the Employment (as % of male employment) in Agriculture and Employment (as % of male employment) in Services?
Your response must be concise. -48.3. In the year 1992, what is the difference between the Employment (as % of male employment) of Industry and Employment (as % of male employment) of Services?
Ensure brevity in your answer.  -14.5. In the year 1992, what is the difference between the Employment (as % of male employment) in Industry and Employment (as % of male employment) in Self-employed?
Your answer should be very brief. 22.3. In the year 1992, what is the difference between the Employment (as % of male employment) of Services and Employment (as % of male employment) of Self-employed?
Ensure brevity in your answer.  36.8. In the year 1993, what is the difference between the Employment (as % of male employment) of Agriculture and Employment (as % of male employment) of Industry?
Your answer should be very brief. -34.1. In the year 1993, what is the difference between the Employment (as % of male employment) in Agriculture and Employment (as % of male employment) in Services?
Offer a very short reply. -49.2. In the year 1993, what is the difference between the Employment (as % of male employment) in Industry and Employment (as % of male employment) in Services?
Your response must be concise. -15.1. In the year 1993, what is the difference between the Employment (as % of male employment) of Industry and Employment (as % of male employment) of Self-employed?
Offer a terse response. 22.9. In the year 1993, what is the difference between the Employment (as % of male employment) in Services and Employment (as % of male employment) in Self-employed?
Give a very brief answer. 38. What is the ratio of the Employment (as % of male employment) in Agriculture in 1985 to that in 1986?
Provide a succinct answer. 1.04. What is the ratio of the Employment (as % of male employment) of Industry in 1985 to that in 1986?
Offer a very short reply. 1.01. What is the ratio of the Employment (as % of male employment) in Self-employed in 1985 to that in 1986?
Ensure brevity in your answer.  1.02. What is the ratio of the Employment (as % of male employment) of Agriculture in 1985 to that in 1987?
Provide a succinct answer. 1.06. What is the ratio of the Employment (as % of male employment) of Industry in 1985 to that in 1987?
Your answer should be very brief. 1.03. What is the ratio of the Employment (as % of male employment) of Services in 1985 to that in 1987?
Offer a very short reply. 0.98. What is the ratio of the Employment (as % of male employment) of Self-employed in 1985 to that in 1987?
Offer a terse response. 1.02. What is the ratio of the Employment (as % of male employment) of Agriculture in 1985 to that in 1988?
Your answer should be very brief. 1.1. What is the ratio of the Employment (as % of male employment) in Services in 1985 to that in 1988?
Your answer should be very brief. 0.98. What is the ratio of the Employment (as % of male employment) of Self-employed in 1985 to that in 1988?
Keep it short and to the point. 1.04. What is the ratio of the Employment (as % of male employment) in Agriculture in 1985 to that in 1989?
Offer a very short reply. 1.13. What is the ratio of the Employment (as % of male employment) of Self-employed in 1985 to that in 1989?
Ensure brevity in your answer.  1.07. What is the ratio of the Employment (as % of male employment) of Agriculture in 1985 to that in 1990?
Provide a succinct answer. 1.21. What is the ratio of the Employment (as % of male employment) in Industry in 1985 to that in 1990?
Your response must be concise. 1.01. What is the ratio of the Employment (as % of male employment) of Services in 1985 to that in 1990?
Your answer should be very brief. 0.97. What is the ratio of the Employment (as % of male employment) of Self-employed in 1985 to that in 1990?
Keep it short and to the point. 1.1. What is the ratio of the Employment (as % of male employment) of Agriculture in 1985 to that in 1991?
Your answer should be very brief. 1.27. What is the ratio of the Employment (as % of male employment) of Industry in 1985 to that in 1991?
Your answer should be compact. 1. What is the ratio of the Employment (as % of male employment) in Services in 1985 to that in 1991?
Ensure brevity in your answer.  0.97. What is the ratio of the Employment (as % of male employment) of Self-employed in 1985 to that in 1991?
Ensure brevity in your answer.  1.16. What is the ratio of the Employment (as % of male employment) in Agriculture in 1985 to that in 1992?
Offer a terse response. 1.31. What is the ratio of the Employment (as % of male employment) in Industry in 1985 to that in 1992?
Your answer should be compact. 0.99. What is the ratio of the Employment (as % of male employment) of Services in 1985 to that in 1992?
Provide a succinct answer. 0.98. What is the ratio of the Employment (as % of male employment) of Self-employed in 1985 to that in 1992?
Your answer should be compact. 1.2. What is the ratio of the Employment (as % of male employment) in Agriculture in 1985 to that in 1993?
Your answer should be very brief. 1.41. What is the ratio of the Employment (as % of male employment) in Services in 1985 to that in 1993?
Ensure brevity in your answer.  0.97. What is the ratio of the Employment (as % of male employment) of Self-employed in 1985 to that in 1993?
Your answer should be very brief. 1.25. What is the ratio of the Employment (as % of male employment) of Agriculture in 1986 to that in 1987?
Provide a short and direct response. 1.01. What is the ratio of the Employment (as % of male employment) of Industry in 1986 to that in 1987?
Make the answer very short. 1.02. What is the ratio of the Employment (as % of male employment) in Services in 1986 to that in 1987?
Provide a succinct answer. 0.99. What is the ratio of the Employment (as % of male employment) in Agriculture in 1986 to that in 1988?
Your response must be concise. 1.06. What is the ratio of the Employment (as % of male employment) of Industry in 1986 to that in 1988?
Provide a short and direct response. 1. What is the ratio of the Employment (as % of male employment) in Services in 1986 to that in 1988?
Offer a terse response. 0.99. What is the ratio of the Employment (as % of male employment) of Agriculture in 1986 to that in 1989?
Offer a terse response. 1.09. What is the ratio of the Employment (as % of male employment) of Industry in 1986 to that in 1989?
Keep it short and to the point. 1. What is the ratio of the Employment (as % of male employment) of Services in 1986 to that in 1989?
Your response must be concise. 0.99. What is the ratio of the Employment (as % of male employment) in Self-employed in 1986 to that in 1989?
Ensure brevity in your answer.  1.05. What is the ratio of the Employment (as % of male employment) of Agriculture in 1986 to that in 1990?
Keep it short and to the point. 1.16. What is the ratio of the Employment (as % of male employment) of Industry in 1986 to that in 1990?
Your answer should be compact. 1. What is the ratio of the Employment (as % of male employment) of Services in 1986 to that in 1990?
Keep it short and to the point. 0.98. What is the ratio of the Employment (as % of male employment) of Self-employed in 1986 to that in 1990?
Keep it short and to the point. 1.08. What is the ratio of the Employment (as % of male employment) of Agriculture in 1986 to that in 1991?
Ensure brevity in your answer.  1.22. What is the ratio of the Employment (as % of male employment) in Services in 1986 to that in 1991?
Give a very brief answer. 0.98. What is the ratio of the Employment (as % of male employment) of Self-employed in 1986 to that in 1991?
Offer a terse response. 1.13. What is the ratio of the Employment (as % of male employment) in Agriculture in 1986 to that in 1992?
Keep it short and to the point. 1.26. What is the ratio of the Employment (as % of male employment) of Industry in 1986 to that in 1992?
Keep it short and to the point. 0.98. What is the ratio of the Employment (as % of male employment) of Services in 1986 to that in 1992?
Offer a terse response. 0.99. What is the ratio of the Employment (as % of male employment) in Self-employed in 1986 to that in 1992?
Keep it short and to the point. 1.18. What is the ratio of the Employment (as % of male employment) in Agriculture in 1986 to that in 1993?
Your response must be concise. 1.35. What is the ratio of the Employment (as % of male employment) of Industry in 1986 to that in 1993?
Provide a succinct answer. 0.98. What is the ratio of the Employment (as % of male employment) in Services in 1986 to that in 1993?
Your response must be concise. 0.98. What is the ratio of the Employment (as % of male employment) in Self-employed in 1986 to that in 1993?
Offer a very short reply. 1.23. What is the ratio of the Employment (as % of male employment) in Agriculture in 1987 to that in 1988?
Give a very brief answer. 1.04. What is the ratio of the Employment (as % of male employment) in Industry in 1987 to that in 1988?
Make the answer very short. 0.99. What is the ratio of the Employment (as % of male employment) of Services in 1987 to that in 1988?
Give a very brief answer. 1.01. What is the ratio of the Employment (as % of male employment) in Agriculture in 1987 to that in 1989?
Give a very brief answer. 1.07. What is the ratio of the Employment (as % of male employment) in Self-employed in 1987 to that in 1989?
Your response must be concise. 1.05. What is the ratio of the Employment (as % of male employment) of Self-employed in 1987 to that in 1990?
Offer a terse response. 1.08. What is the ratio of the Employment (as % of male employment) of Agriculture in 1987 to that in 1991?
Make the answer very short. 1.2. What is the ratio of the Employment (as % of male employment) in Industry in 1987 to that in 1991?
Your answer should be very brief. 0.97. What is the ratio of the Employment (as % of male employment) of Services in 1987 to that in 1991?
Your answer should be compact. 1. What is the ratio of the Employment (as % of male employment) of Self-employed in 1987 to that in 1991?
Provide a succinct answer. 1.13. What is the ratio of the Employment (as % of male employment) in Agriculture in 1987 to that in 1992?
Offer a terse response. 1.24. What is the ratio of the Employment (as % of male employment) in Industry in 1987 to that in 1992?
Keep it short and to the point. 0.96. What is the ratio of the Employment (as % of male employment) of Self-employed in 1987 to that in 1992?
Your response must be concise. 1.18. What is the ratio of the Employment (as % of male employment) of Agriculture in 1987 to that in 1993?
Your answer should be very brief. 1.33. What is the ratio of the Employment (as % of male employment) of Industry in 1987 to that in 1993?
Offer a terse response. 0.96. What is the ratio of the Employment (as % of male employment) of Self-employed in 1987 to that in 1993?
Give a very brief answer. 1.23. What is the ratio of the Employment (as % of male employment) of Agriculture in 1988 to that in 1989?
Your answer should be very brief. 1.03. What is the ratio of the Employment (as % of male employment) in Self-employed in 1988 to that in 1989?
Provide a short and direct response. 1.03. What is the ratio of the Employment (as % of male employment) in Agriculture in 1988 to that in 1990?
Keep it short and to the point. 1.1. What is the ratio of the Employment (as % of male employment) of Services in 1988 to that in 1990?
Your answer should be compact. 0.99. What is the ratio of the Employment (as % of male employment) in Self-employed in 1988 to that in 1990?
Provide a succinct answer. 1.06. What is the ratio of the Employment (as % of male employment) of Agriculture in 1988 to that in 1991?
Your answer should be compact. 1.15. What is the ratio of the Employment (as % of male employment) of Industry in 1988 to that in 1991?
Give a very brief answer. 0.99. What is the ratio of the Employment (as % of male employment) of Services in 1988 to that in 1991?
Provide a short and direct response. 0.99. What is the ratio of the Employment (as % of male employment) in Agriculture in 1988 to that in 1992?
Ensure brevity in your answer.  1.19. What is the ratio of the Employment (as % of male employment) in Industry in 1988 to that in 1992?
Your answer should be compact. 0.97. What is the ratio of the Employment (as % of male employment) of Services in 1988 to that in 1992?
Keep it short and to the point. 1. What is the ratio of the Employment (as % of male employment) in Self-employed in 1988 to that in 1992?
Offer a very short reply. 1.16. What is the ratio of the Employment (as % of male employment) in Agriculture in 1988 to that in 1993?
Keep it short and to the point. 1.28. What is the ratio of the Employment (as % of male employment) in Industry in 1988 to that in 1993?
Offer a very short reply. 0.98. What is the ratio of the Employment (as % of male employment) of Services in 1988 to that in 1993?
Provide a succinct answer. 0.99. What is the ratio of the Employment (as % of male employment) in Self-employed in 1988 to that in 1993?
Your response must be concise. 1.2. What is the ratio of the Employment (as % of male employment) of Agriculture in 1989 to that in 1990?
Give a very brief answer. 1.06. What is the ratio of the Employment (as % of male employment) in Industry in 1989 to that in 1990?
Give a very brief answer. 1. What is the ratio of the Employment (as % of male employment) in Services in 1989 to that in 1990?
Offer a terse response. 0.99. What is the ratio of the Employment (as % of male employment) of Self-employed in 1989 to that in 1990?
Give a very brief answer. 1.03. What is the ratio of the Employment (as % of male employment) in Agriculture in 1989 to that in 1991?
Your answer should be very brief. 1.12. What is the ratio of the Employment (as % of male employment) of Industry in 1989 to that in 1991?
Provide a short and direct response. 0.99. What is the ratio of the Employment (as % of male employment) of Services in 1989 to that in 1991?
Provide a short and direct response. 1. What is the ratio of the Employment (as % of male employment) in Self-employed in 1989 to that in 1991?
Ensure brevity in your answer.  1.08. What is the ratio of the Employment (as % of male employment) in Agriculture in 1989 to that in 1992?
Offer a very short reply. 1.16. What is the ratio of the Employment (as % of male employment) of Industry in 1989 to that in 1992?
Give a very brief answer. 0.97. What is the ratio of the Employment (as % of male employment) in Services in 1989 to that in 1992?
Offer a terse response. 1. What is the ratio of the Employment (as % of male employment) in Self-employed in 1989 to that in 1992?
Give a very brief answer. 1.12. What is the ratio of the Employment (as % of male employment) in Agriculture in 1989 to that in 1993?
Provide a short and direct response. 1.24. What is the ratio of the Employment (as % of male employment) in Industry in 1989 to that in 1993?
Your answer should be very brief. 0.98. What is the ratio of the Employment (as % of male employment) in Self-employed in 1989 to that in 1993?
Provide a short and direct response. 1.17. What is the ratio of the Employment (as % of male employment) of Industry in 1990 to that in 1991?
Your answer should be very brief. 0.99. What is the ratio of the Employment (as % of male employment) of Services in 1990 to that in 1991?
Offer a very short reply. 1. What is the ratio of the Employment (as % of male employment) of Self-employed in 1990 to that in 1991?
Offer a very short reply. 1.05. What is the ratio of the Employment (as % of male employment) of Agriculture in 1990 to that in 1992?
Offer a very short reply. 1.09. What is the ratio of the Employment (as % of male employment) of Industry in 1990 to that in 1992?
Provide a succinct answer. 0.97. What is the ratio of the Employment (as % of male employment) of Services in 1990 to that in 1992?
Provide a succinct answer. 1.01. What is the ratio of the Employment (as % of male employment) in Self-employed in 1990 to that in 1992?
Offer a terse response. 1.09. What is the ratio of the Employment (as % of male employment) in Industry in 1990 to that in 1993?
Provide a short and direct response. 0.98. What is the ratio of the Employment (as % of male employment) of Services in 1990 to that in 1993?
Your response must be concise. 1. What is the ratio of the Employment (as % of male employment) of Self-employed in 1990 to that in 1993?
Provide a short and direct response. 1.14. What is the ratio of the Employment (as % of male employment) of Agriculture in 1991 to that in 1992?
Your answer should be very brief. 1.03. What is the ratio of the Employment (as % of male employment) of Industry in 1991 to that in 1992?
Provide a short and direct response. 0.99. What is the ratio of the Employment (as % of male employment) in Services in 1991 to that in 1992?
Provide a short and direct response. 1.01. What is the ratio of the Employment (as % of male employment) of Self-employed in 1991 to that in 1992?
Offer a terse response. 1.04. What is the ratio of the Employment (as % of male employment) in Agriculture in 1991 to that in 1993?
Make the answer very short. 1.11. What is the ratio of the Employment (as % of male employment) of Industry in 1991 to that in 1993?
Provide a succinct answer. 0.99. What is the ratio of the Employment (as % of male employment) in Services in 1991 to that in 1993?
Offer a very short reply. 1. What is the ratio of the Employment (as % of male employment) of Self-employed in 1991 to that in 1993?
Offer a terse response. 1.08. What is the ratio of the Employment (as % of male employment) of Agriculture in 1992 to that in 1993?
Ensure brevity in your answer.  1.07. What is the ratio of the Employment (as % of male employment) of Services in 1992 to that in 1993?
Ensure brevity in your answer.  0.99. What is the ratio of the Employment (as % of male employment) of Self-employed in 1992 to that in 1993?
Your answer should be compact. 1.04. What is the difference between the highest and the second highest Employment (as % of male employment) of Agriculture?
Your answer should be compact. 0.3. What is the difference between the highest and the second highest Employment (as % of male employment) of Industry?
Make the answer very short. 0.1. What is the difference between the highest and the lowest Employment (as % of male employment) of Services?
Your answer should be compact. 1.7. 